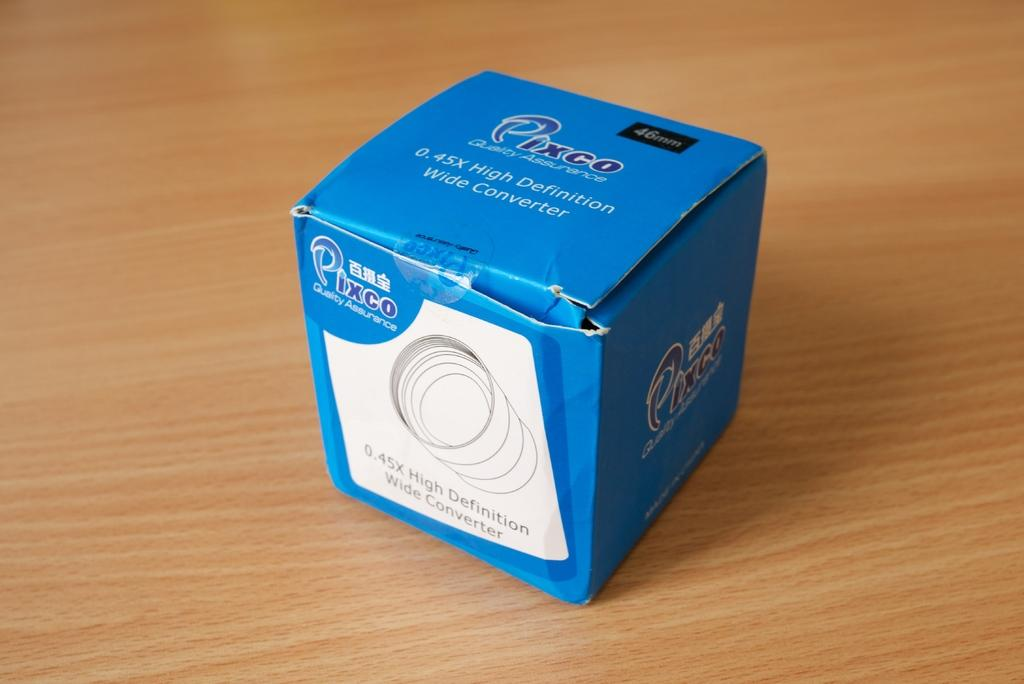<image>
Summarize the visual content of the image. a blue box with a lens for Pixco 